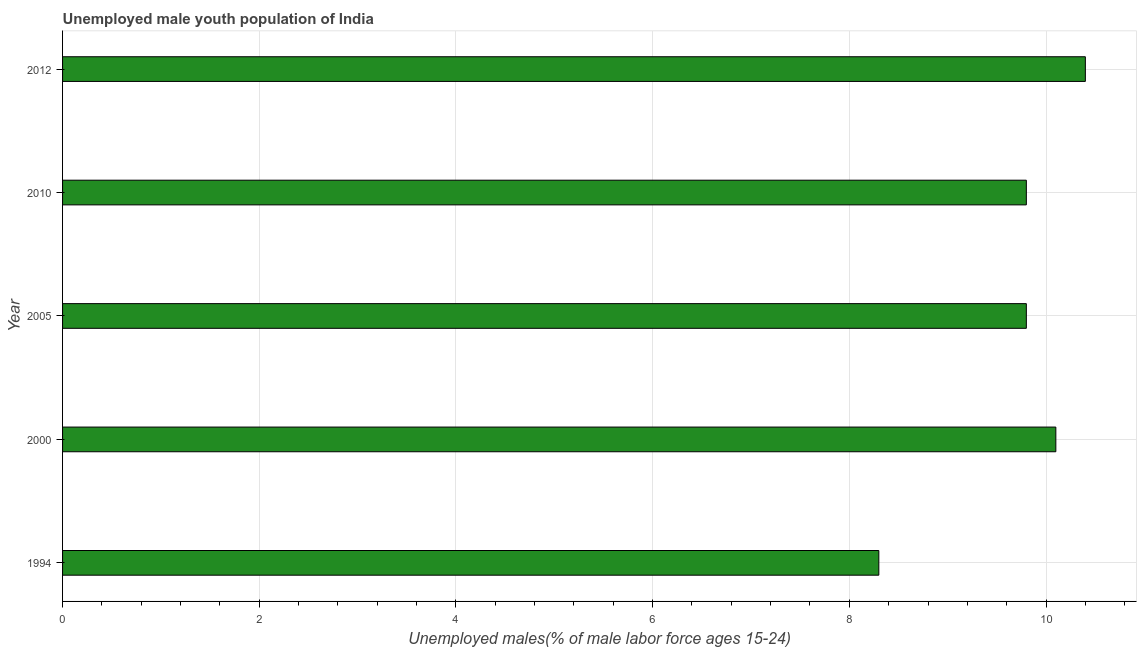What is the title of the graph?
Your answer should be very brief. Unemployed male youth population of India. What is the label or title of the X-axis?
Give a very brief answer. Unemployed males(% of male labor force ages 15-24). What is the unemployed male youth in 2012?
Provide a succinct answer. 10.4. Across all years, what is the maximum unemployed male youth?
Your answer should be very brief. 10.4. Across all years, what is the minimum unemployed male youth?
Your response must be concise. 8.3. In which year was the unemployed male youth maximum?
Make the answer very short. 2012. In which year was the unemployed male youth minimum?
Your response must be concise. 1994. What is the sum of the unemployed male youth?
Your answer should be very brief. 48.4. What is the average unemployed male youth per year?
Offer a terse response. 9.68. What is the median unemployed male youth?
Provide a succinct answer. 9.8. Do a majority of the years between 2000 and 2010 (inclusive) have unemployed male youth greater than 5.2 %?
Your answer should be compact. Yes. What is the ratio of the unemployed male youth in 2000 to that in 2010?
Your answer should be very brief. 1.03. What is the difference between the highest and the second highest unemployed male youth?
Offer a terse response. 0.3. What is the difference between the highest and the lowest unemployed male youth?
Give a very brief answer. 2.1. In how many years, is the unemployed male youth greater than the average unemployed male youth taken over all years?
Give a very brief answer. 4. How many bars are there?
Provide a succinct answer. 5. What is the difference between two consecutive major ticks on the X-axis?
Ensure brevity in your answer.  2. What is the Unemployed males(% of male labor force ages 15-24) in 1994?
Offer a very short reply. 8.3. What is the Unemployed males(% of male labor force ages 15-24) of 2000?
Your answer should be very brief. 10.1. What is the Unemployed males(% of male labor force ages 15-24) in 2005?
Your answer should be very brief. 9.8. What is the Unemployed males(% of male labor force ages 15-24) in 2010?
Your answer should be very brief. 9.8. What is the Unemployed males(% of male labor force ages 15-24) in 2012?
Your response must be concise. 10.4. What is the difference between the Unemployed males(% of male labor force ages 15-24) in 1994 and 2005?
Your answer should be very brief. -1.5. What is the difference between the Unemployed males(% of male labor force ages 15-24) in 1994 and 2010?
Provide a succinct answer. -1.5. What is the difference between the Unemployed males(% of male labor force ages 15-24) in 1994 and 2012?
Make the answer very short. -2.1. What is the difference between the Unemployed males(% of male labor force ages 15-24) in 2000 and 2010?
Your answer should be very brief. 0.3. What is the difference between the Unemployed males(% of male labor force ages 15-24) in 2000 and 2012?
Provide a short and direct response. -0.3. What is the difference between the Unemployed males(% of male labor force ages 15-24) in 2005 and 2010?
Your response must be concise. 0. What is the ratio of the Unemployed males(% of male labor force ages 15-24) in 1994 to that in 2000?
Keep it short and to the point. 0.82. What is the ratio of the Unemployed males(% of male labor force ages 15-24) in 1994 to that in 2005?
Make the answer very short. 0.85. What is the ratio of the Unemployed males(% of male labor force ages 15-24) in 1994 to that in 2010?
Your answer should be compact. 0.85. What is the ratio of the Unemployed males(% of male labor force ages 15-24) in 1994 to that in 2012?
Offer a terse response. 0.8. What is the ratio of the Unemployed males(% of male labor force ages 15-24) in 2000 to that in 2005?
Provide a short and direct response. 1.03. What is the ratio of the Unemployed males(% of male labor force ages 15-24) in 2000 to that in 2010?
Ensure brevity in your answer.  1.03. What is the ratio of the Unemployed males(% of male labor force ages 15-24) in 2005 to that in 2012?
Offer a terse response. 0.94. What is the ratio of the Unemployed males(% of male labor force ages 15-24) in 2010 to that in 2012?
Provide a succinct answer. 0.94. 